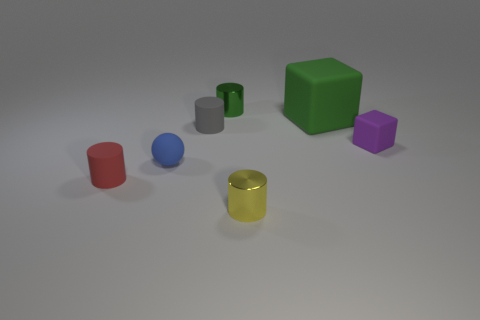What material is the small object that is the same color as the large matte cube?
Make the answer very short. Metal. There is a rubber cylinder in front of the blue matte object; what size is it?
Make the answer very short. Small. How many objects are yellow shiny cylinders or things that are in front of the large rubber block?
Provide a succinct answer. 5. How many other objects are there of the same size as the purple object?
Your answer should be compact. 5. What material is the tiny purple object that is the same shape as the large thing?
Offer a very short reply. Rubber. Is the number of small gray cylinders on the left side of the tiny matte block greater than the number of big gray metal cylinders?
Your answer should be very brief. Yes. Are there any other things of the same color as the big matte thing?
Provide a succinct answer. Yes. What is the shape of the other small object that is made of the same material as the small green thing?
Your answer should be compact. Cylinder. Do the cube that is to the left of the purple rubber object and the red cylinder have the same material?
Offer a terse response. Yes. There is a tiny thing that is the same color as the large rubber block; what shape is it?
Give a very brief answer. Cylinder. 